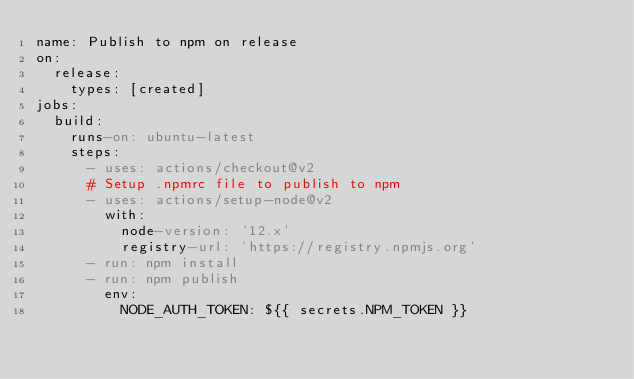<code> <loc_0><loc_0><loc_500><loc_500><_YAML_>name: Publish to npm on release
on:
  release:
    types: [created]
jobs:
  build:
    runs-on: ubuntu-latest
    steps:
      - uses: actions/checkout@v2
      # Setup .npmrc file to publish to npm
      - uses: actions/setup-node@v2
        with:
          node-version: '12.x'
          registry-url: 'https://registry.npmjs.org'
      - run: npm install
      - run: npm publish
        env:
          NODE_AUTH_TOKEN: ${{ secrets.NPM_TOKEN }}
</code> 